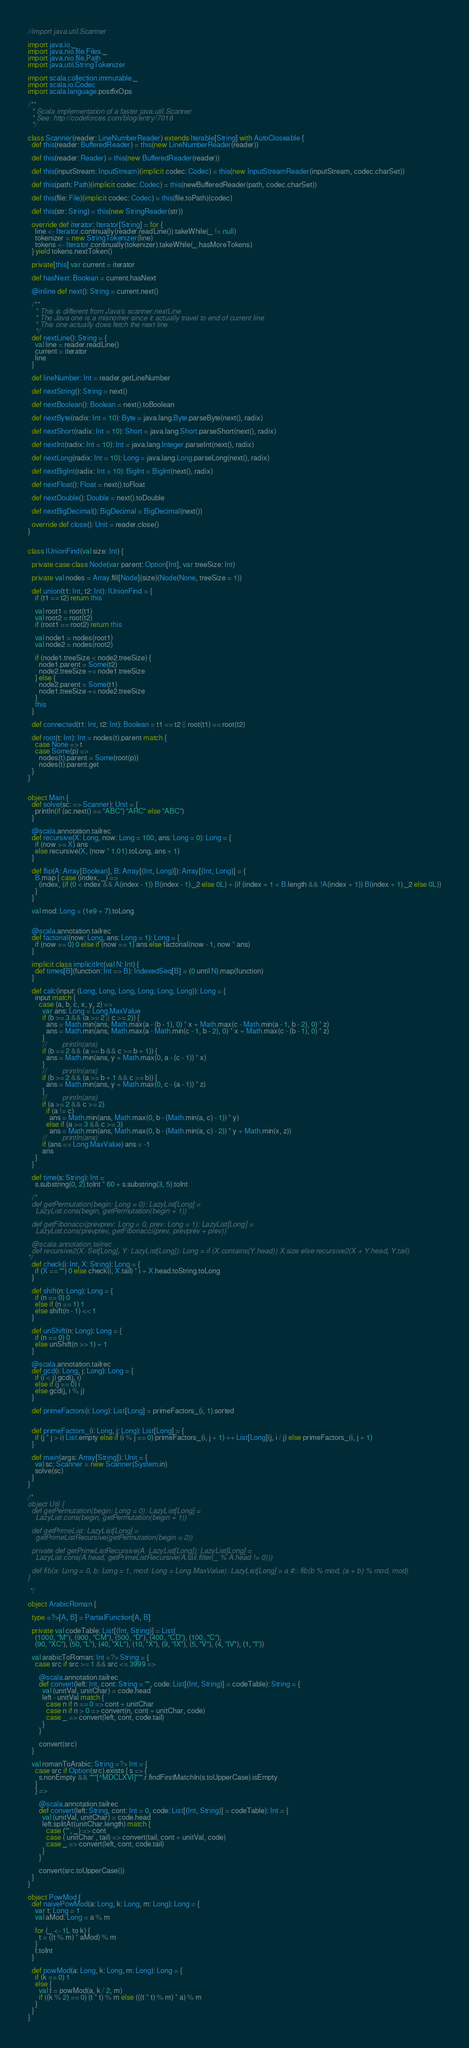Convert code to text. <code><loc_0><loc_0><loc_500><loc_500><_Scala_>//import java.util.Scanner

import java.io._
import java.nio.file.Files._
import java.nio.file.Path
import java.util.StringTokenizer

import scala.collection.immutable._
import scala.io.Codec
import scala.language.postfixOps

/**
  * Scala implementation of a faster java.util.Scanner
  * See: http://codeforces.com/blog/entry/7018
  */

class Scanner(reader: LineNumberReader) extends Iterable[String] with AutoCloseable {
  def this(reader: BufferedReader) = this(new LineNumberReader(reader))

  def this(reader: Reader) = this(new BufferedReader(reader))

  def this(inputStream: InputStream)(implicit codec: Codec) = this(new InputStreamReader(inputStream, codec.charSet))

  def this(path: Path)(implicit codec: Codec) = this(newBufferedReader(path, codec.charSet))

  def this(file: File)(implicit codec: Codec) = this(file.toPath)(codec)

  def this(str: String) = this(new StringReader(str))

  override def iterator: Iterator[String] = for {
    line <- Iterator.continually(reader.readLine()).takeWhile(_ != null)
    tokenizer = new StringTokenizer(line)
    tokens <- Iterator.continually(tokenizer).takeWhile(_.hasMoreTokens)
  } yield tokens.nextToken()

  private[this] var current = iterator

  def hasNext: Boolean = current.hasNext

  @inline def next(): String = current.next()

  /**
    * This is different from Java's scanner.nextLine
    * The Java one is a misnomer since it actually travel to end of current line
    * This one actually does fetch the next line
    */
  def nextLine(): String = {
    val line = reader.readLine()
    current = iterator
    line
  }

  def lineNumber: Int = reader.getLineNumber

  def nextString(): String = next()

  def nextBoolean(): Boolean = next().toBoolean

  def nextByte(radix: Int = 10): Byte = java.lang.Byte.parseByte(next(), radix)

  def nextShort(radix: Int = 10): Short = java.lang.Short.parseShort(next(), radix)

  def nextInt(radix: Int = 10): Int = java.lang.Integer.parseInt(next(), radix)

  def nextLong(radix: Int = 10): Long = java.lang.Long.parseLong(next(), radix)

  def nextBigInt(radix: Int = 10): BigInt = BigInt(next(), radix)

  def nextFloat(): Float = next().toFloat

  def nextDouble(): Double = next().toDouble

  def nextBigDecimal(): BigDecimal = BigDecimal(next())

  override def close(): Unit = reader.close()
}


class IUnionFind(val size: Int) {

  private case class Node(var parent: Option[Int], var treeSize: Int)

  private val nodes = Array.fill[Node](size)(Node(None, treeSize = 1))

  def union(t1: Int, t2: Int): IUnionFind = {
    if (t1 == t2) return this

    val root1 = root(t1)
    val root2 = root(t2)
    if (root1 == root2) return this

    val node1 = nodes(root1)
    val node2 = nodes(root2)

    if (node1.treeSize < node2.treeSize) {
      node1.parent = Some(t2)
      node2.treeSize += node1.treeSize
    } else {
      node2.parent = Some(t1)
      node1.treeSize += node2.treeSize
    }
    this
  }

  def connected(t1: Int, t2: Int): Boolean = t1 == t2 || root(t1) == root(t2)

  def root(t: Int): Int = nodes(t).parent match {
    case None => t
    case Some(p) =>
      nodes(t).parent = Some(root(p))
      nodes(t).parent.get
  }
}


object Main {
  def solve(sc: => Scanner): Unit = {
    println(if (sc.next() == "ABC") "ARC" else "ABC")
  }

  @scala.annotation.tailrec
  def recursive(X: Long, now: Long = 100, ans: Long = 0): Long = {
    if (now >= X) ans
    else recursive(X, (now * 1.01).toLong, ans + 1)
  }

  def flip(A: Array[Boolean], B: Array[(Int, Long)]): Array[(Int, Long)] = {
    B.map { case (index, _) =>
      (index, (if (0 < index && A(index - 1)) B(index - 1)._2 else 0L) + (if (index + 1 < B.length && !A(index + 1)) B(index + 1)._2 else 0L))
    }
  }

  val mod: Long = (1e9 + 7).toLong


  @scala.annotation.tailrec
  def factorial(now: Long, ans: Long = 1): Long = {
    if (now == 0) 0 else if (now == 1) ans else factorial(now - 1, now * ans)
  }

  implicit class implicitInt(val N: Int) {
    def times[B](function: Int => B): IndexedSeq[B] = (0 until N).map(function)
  }

  def calc(input: (Long, Long, Long, Long, Long, Long)): Long = {
    input match {
      case (a, b, c, x, y, z) =>
        var ans: Long = Long.MaxValue
        if (b >= 3 && (a >= 2 || c >= 2)) {
          ans = Math.min(ans, Math.max(a - (b - 1), 0) * x + Math.max(c - Math.min(a - 1, b - 2), 0) * z)
          ans = Math.min(ans, Math.max(a - Math.min(c - 1, b - 2), 0) * x + Math.max(c - (b - 1), 0) * z)
        }
        //        println(ans)
        if (b >= 2 && (a >= b && c >= b + 1)) {
          ans = Math.min(ans, y + Math.max(0, a - (c - 1)) * x)
        }
        //        println(ans)
        if (b >= 2 && (a >= b + 1 && c >= b)) {
          ans = Math.min(ans, y + Math.max(0, c - (a - 1)) * z)
        }
        //        println(ans)
        if (a >= 2 && c >= 2)
          if (a != c)
            ans = Math.min(ans, Math.max(0, b - (Math.min(a, c) - 1)) * y)
          else if (a >= 3 && c >= 3)
            ans = Math.min(ans, Math.max(0, b - (Math.min(a, c) - 2)) * y + Math.min(x, z))
        //        println(ans)
        if (ans == Long.MaxValue) ans = -1
        ans
    }
  }

  def time(s: String): Int =
    s.substring(0, 2).toInt * 60 + s.substring(3, 5).toInt

  /*
  def getPermutation(begin: Long = 0): LazyList[Long] =
    LazyList.cons(begin, getPermutation(begin + 1))

  def getFibonacci(prevprev: Long = 0, prev: Long = 1): LazyList[Long] =
    LazyList.cons(prevprev, getFibonacci(prev, prevprev + prev))

  @scala.annotation.tailrec
  def recursive2(X: Set[Long], Y: LazyList[Long]): Long = if (X.contains(Y.head)) X.size else recursive2(X + Y.head, Y.tail)
*/
  def check(i: Int, X: String): Long = {
    if (X == "") 0 else check(i, X.tail) * i + X.head.toString.toLong
  }

  def shift(n: Long): Long = {
    if (n == 0) 0
    else if (n == 1) 1
    else shift(n - 1) << 1
  }

  def unShift(n: Long): Long = {
    if (n == 0) 0
    else unShift(n >> 1) + 1
  }

  @scala.annotation.tailrec
  def gcd(i: Long, j: Long): Long = {
    if (i < j) gcd(j, i)
    else if (j == 0) i
    else gcd(j, i % j)
  }

  def primeFactors(i: Long): List[Long] = primeFactors_(i, 1).sorted


  def primeFactors_(i: Long, j: Long): List[Long] = {
    if (j * j > i) List.empty else if (i % j == 0) primeFactors_(i, j + 1) ++ List[Long](j, i / j) else primeFactors_(i, j + 1)
  }

  def main(args: Array[String]): Unit = {
    val sc: Scanner = new Scanner(System.in)
    solve(sc)
  }
}

/*
object Util {
  def getPermutation(begin: Long = 0): LazyList[Long] =
    LazyList.cons(begin, getPermutation(begin + 1))

  def getPrimeList: LazyList[Long] =
    getPrimeListRecursive(getPermutation(begin = 2))

  private def getPrimeListRecursive(A: LazyList[Long]): LazyList[Long] =
    LazyList.cons(A.head, getPrimeListRecursive(A.tail.filter(_ % A.head != 0)))

  def fib(a: Long = 0, b: Long = 1, mod: Long = Long.MaxValue): LazyList[Long] = a #:: fib(b % mod, (a + b) % mod, mod)
}

 */

object ArabicRoman {

  type =?>[A, B] = PartialFunction[A, B]

  private val codeTable: List[(Int, String)] = List(
    (1000, "M"), (900, "CM"), (500, "D"), (400, "CD"), (100, "C"),
    (90, "XC"), (50, "L"), (40, "XL"), (10, "X"), (9, "IX"), (5, "V"), (4, "IV"), (1, "I"))

  val arabicToRoman: Int =?> String = {
    case src if src >= 1 && src <= 3999 =>

      @scala.annotation.tailrec
      def convert(left: Int, cont: String = "", code: List[(Int, String)] = codeTable): String = {
        val (unitVal, unitChar) = code.head
        left - unitVal match {
          case n if n == 0 => cont + unitChar
          case n if n > 0 => convert(n, cont + unitChar, code)
          case _ => convert(left, cont, code.tail)
        }
      }

      convert(src)
  }

  val romanToArabic: String =?> Int = {
    case src if Option(src).exists { s => {
      s.nonEmpty && """[^MDCLXVI]""".r.findFirstMatchIn(s.toUpperCase).isEmpty
    }
    } =>

      @scala.annotation.tailrec
      def convert(left: String, cont: Int = 0, code: List[(Int, String)] = codeTable): Int = {
        val (unitVal, unitChar) = code.head
        left.splitAt(unitChar.length) match {
          case ("", _) => cont
          case (`unitChar`, tail) => convert(tail, cont + unitVal, code)
          case _ => convert(left, cont, code.tail)
        }
      }

      convert(src.toUpperCase())
  }
}

object PowMod {
  def naivePowMod(a: Long, k: Long, m: Long): Long = {
    var t: Long = 1
    val aMod: Long = a % m

    for (_ <- 1L to k) {
      t = ((t % m) * aMod) % m
    }
    t.toInt
  }

  def powMod(a: Long, k: Long, m: Long): Long = {
    if (k == 0) 1
    else {
      val t = powMod(a, k / 2, m)
      if ((k % 2) == 0) (t * t) % m else (((t * t) % m) * a) % m
    }
  }
}</code> 